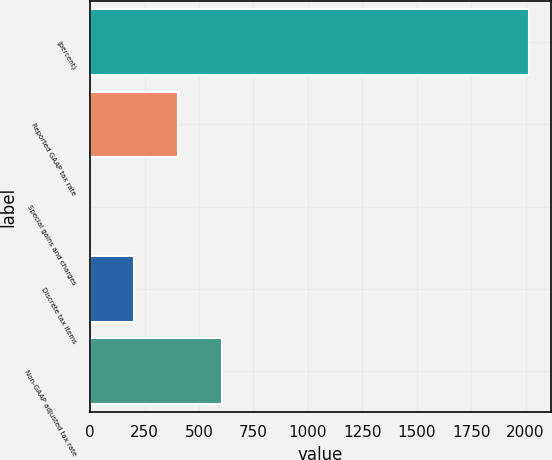<chart> <loc_0><loc_0><loc_500><loc_500><bar_chart><fcel>(percent)<fcel>Reported GAAP tax rate<fcel>Special gains and charges<fcel>Discrete tax items<fcel>Non-GAAP adjusted tax rate<nl><fcel>2015<fcel>403.32<fcel>0.4<fcel>201.86<fcel>604.78<nl></chart> 